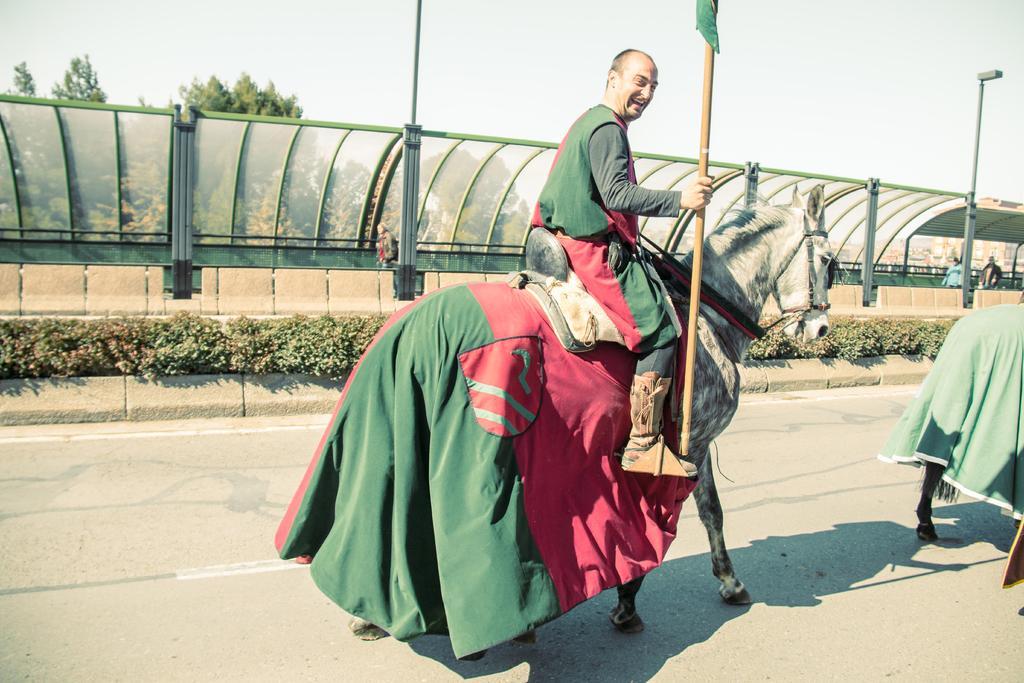In one or two sentences, can you explain what this image depicts? in this picture we see a man riding a horse on the road and we can see a metal fence on the left side and few trees and a pole 